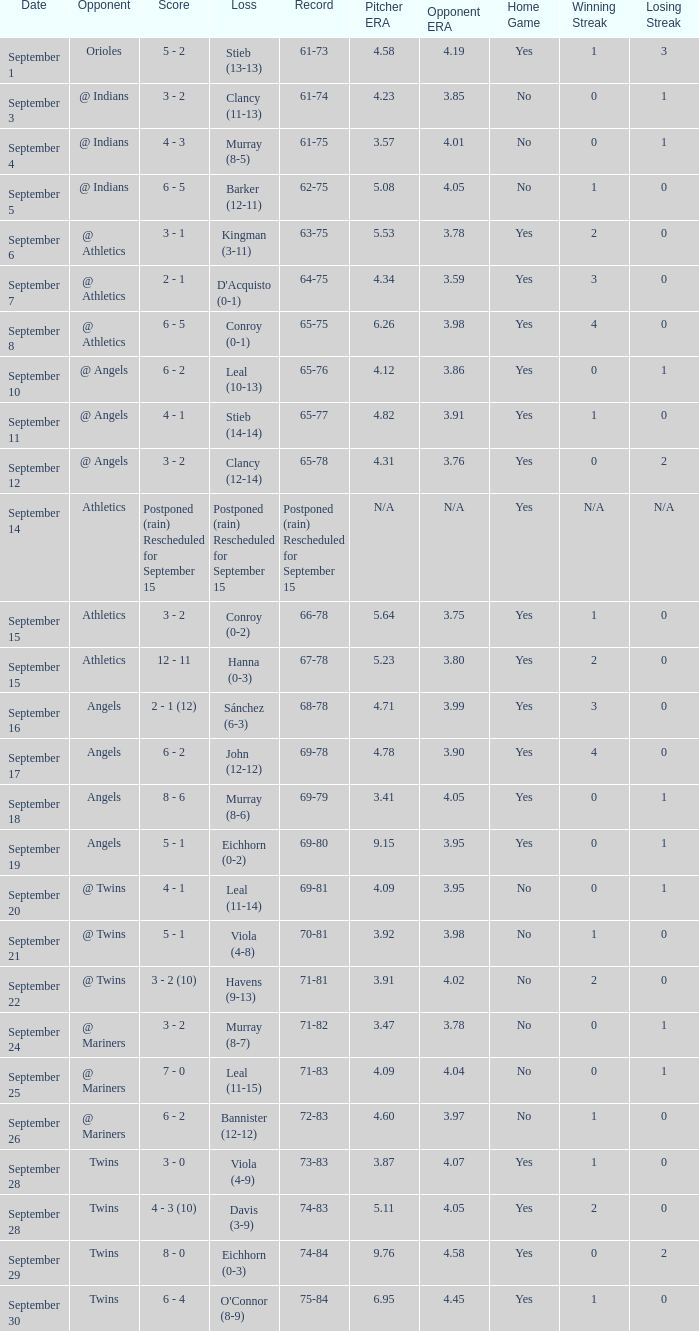Name the date for record of 74-84 September 29. 